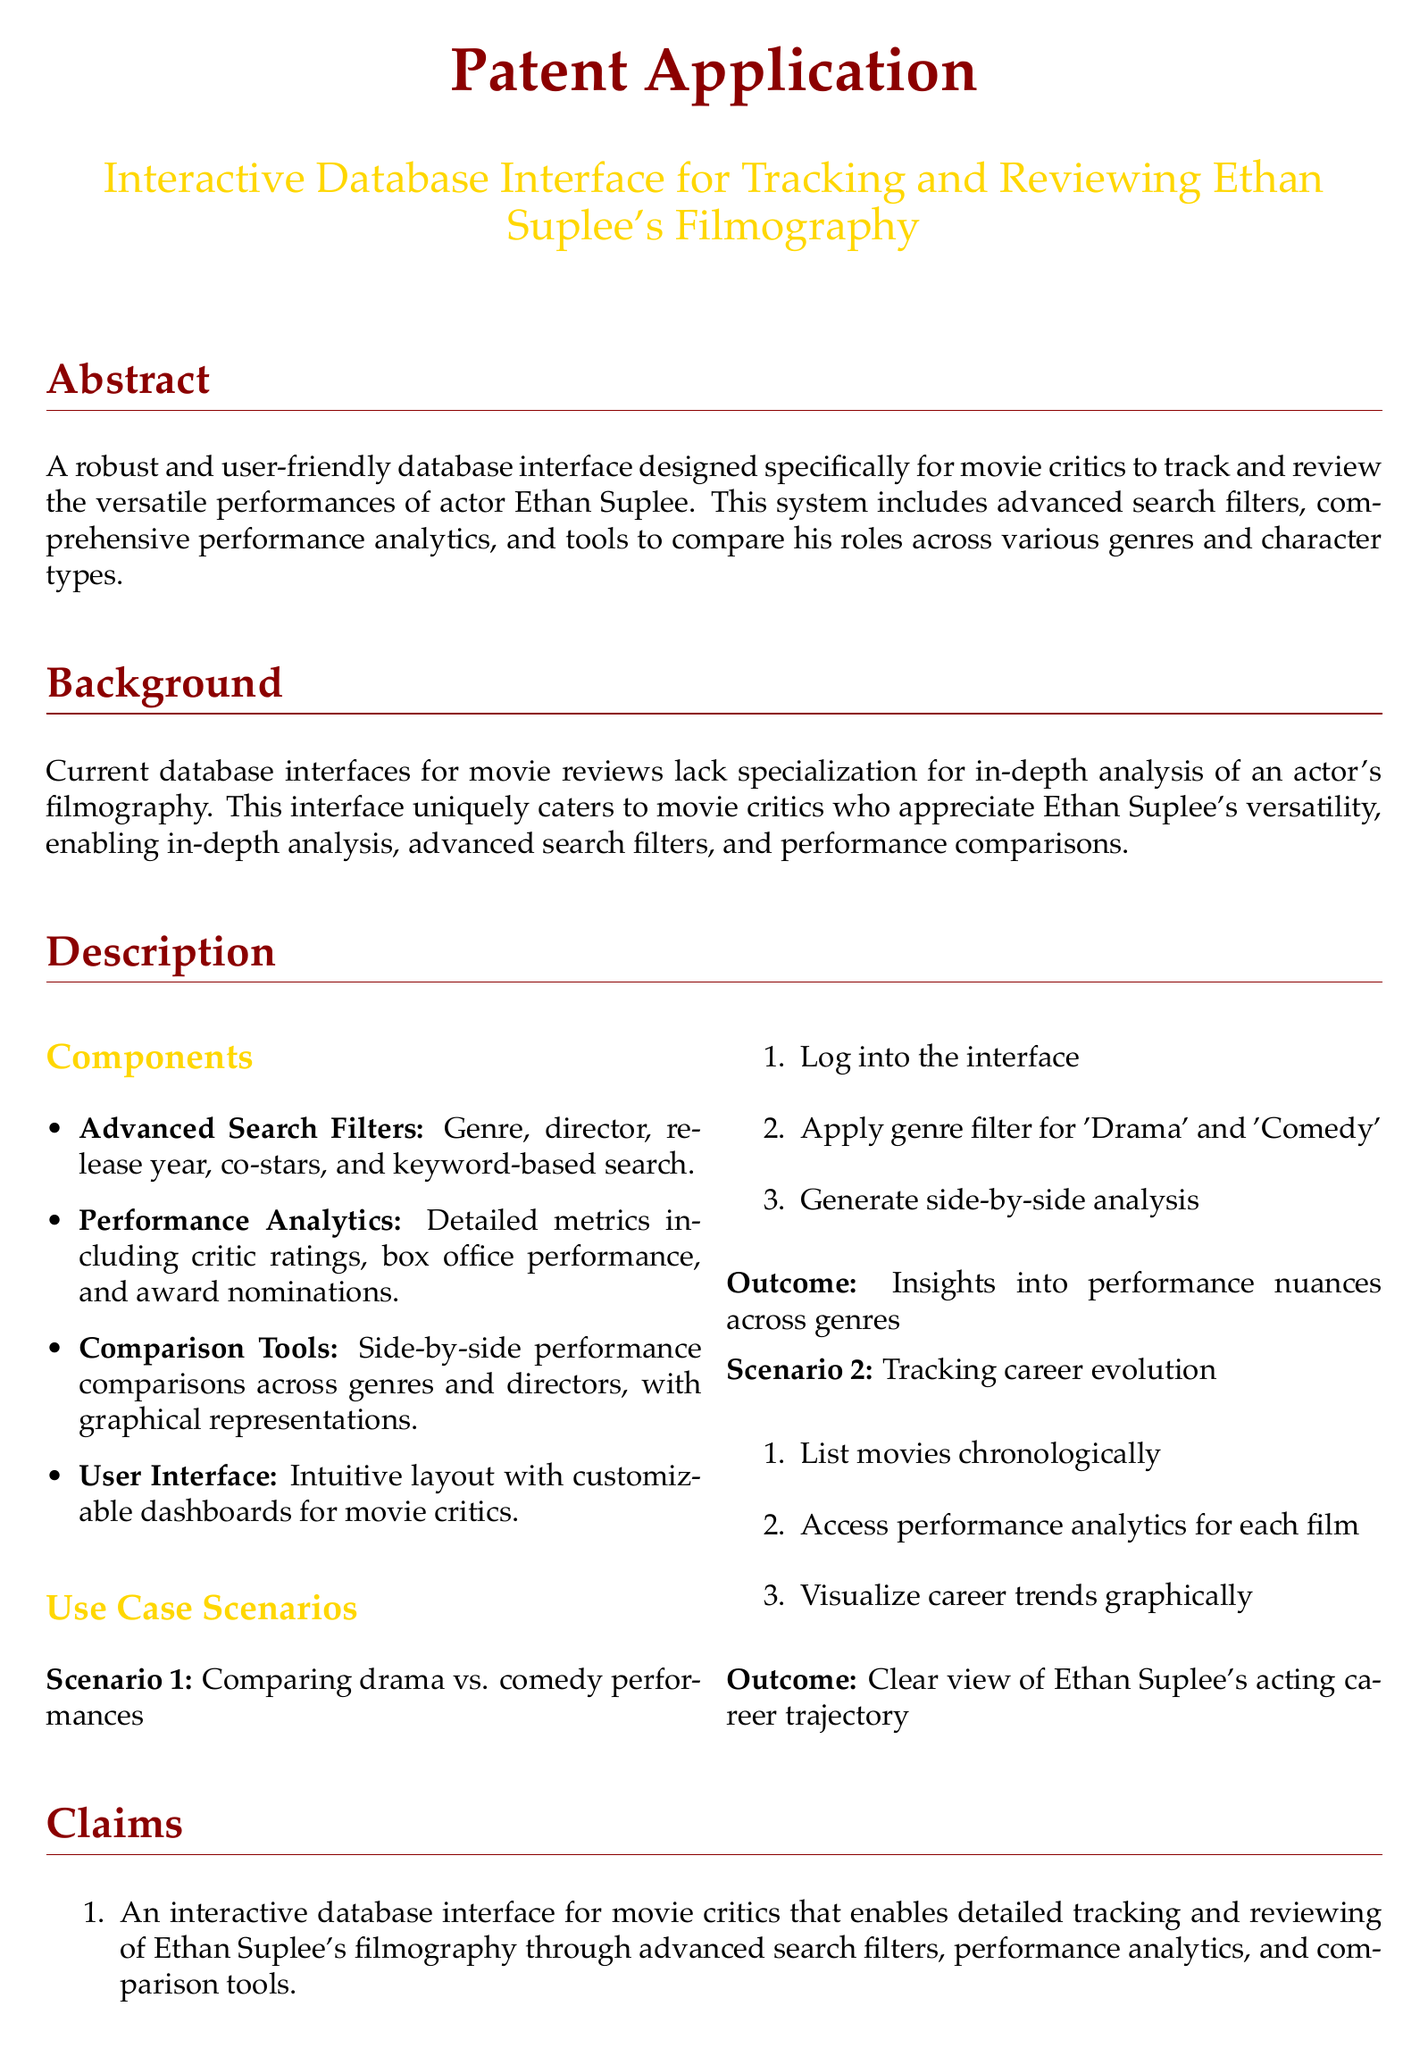What is the title of the patent application? The title is the main identifier for the document and can be found at the beginning of the abstract section.
Answer: Interactive Database Interface for Tracking and Reviewing Ethan Suplee's Filmography What features does the database interface include? The features are listed under the components section, summarizing the main offerings of the system.
Answer: Advanced Search Filters, Performance Analytics, Comparison Tools, User Interface What is the purpose of the advanced search filters? The purpose is to allow users to refine their queries based on various criteria, making it easier to find specific information.
Answer: To filter by genre, director, release year, co-stars, and keywords What is the expected outcome of comparing drama vs. comedy performances? The outcome provides insights into different acting styles according to genre, aiding critics' understanding of performances.
Answer: Insights into performance nuances across genres How many use case scenarios are described in the document? The document outlines specific scenarios to illustrate the application, providing context for its usage.
Answer: Two What does the performance analytics provide? This information details what the analytics section is designed to offer in terms of metrics and evaluation of performances.
Answer: Critic ratings, box office performance, and award nominations What are the claims mentioned in the patent application? Claims articulate the unique aspects and functionalities the patent is asserting, providing legal protection.
Answer: An interactive database interface, performance analytics, side-by-side comparisons What type of document is this? This refers to the legal and procedural nature of the content and structure.
Answer: Patent application 